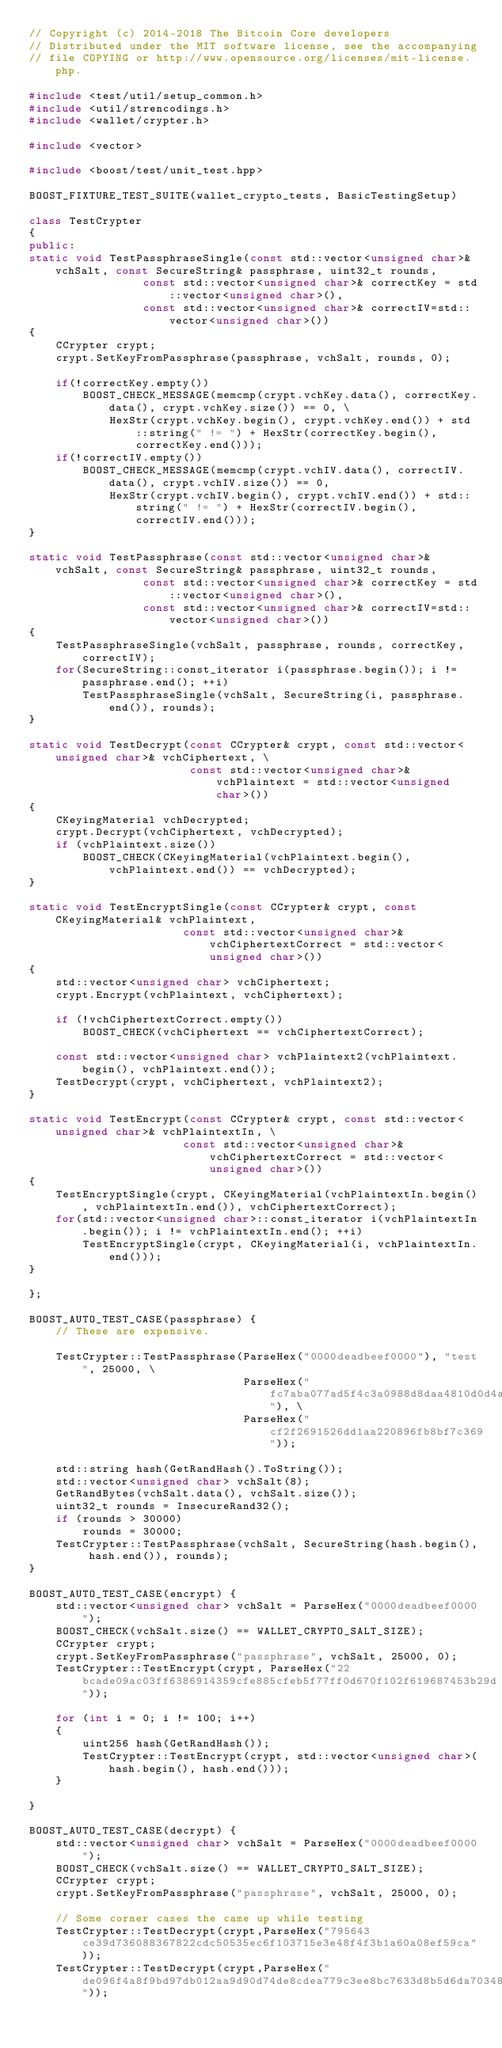<code> <loc_0><loc_0><loc_500><loc_500><_C++_>// Copyright (c) 2014-2018 The Bitcoin Core developers
// Distributed under the MIT software license, see the accompanying
// file COPYING or http://www.opensource.org/licenses/mit-license.php.

#include <test/util/setup_common.h>
#include <util/strencodings.h>
#include <wallet/crypter.h>

#include <vector>

#include <boost/test/unit_test.hpp>

BOOST_FIXTURE_TEST_SUITE(wallet_crypto_tests, BasicTestingSetup)

class TestCrypter
{
public:
static void TestPassphraseSingle(const std::vector<unsigned char>& vchSalt, const SecureString& passphrase, uint32_t rounds,
                 const std::vector<unsigned char>& correctKey = std::vector<unsigned char>(),
                 const std::vector<unsigned char>& correctIV=std::vector<unsigned char>())
{
    CCrypter crypt;
    crypt.SetKeyFromPassphrase(passphrase, vchSalt, rounds, 0);

    if(!correctKey.empty())
        BOOST_CHECK_MESSAGE(memcmp(crypt.vchKey.data(), correctKey.data(), crypt.vchKey.size()) == 0, \
            HexStr(crypt.vchKey.begin(), crypt.vchKey.end()) + std::string(" != ") + HexStr(correctKey.begin(), correctKey.end()));
    if(!correctIV.empty())
        BOOST_CHECK_MESSAGE(memcmp(crypt.vchIV.data(), correctIV.data(), crypt.vchIV.size()) == 0,
            HexStr(crypt.vchIV.begin(), crypt.vchIV.end()) + std::string(" != ") + HexStr(correctIV.begin(), correctIV.end()));
}

static void TestPassphrase(const std::vector<unsigned char>& vchSalt, const SecureString& passphrase, uint32_t rounds,
                 const std::vector<unsigned char>& correctKey = std::vector<unsigned char>(),
                 const std::vector<unsigned char>& correctIV=std::vector<unsigned char>())
{
    TestPassphraseSingle(vchSalt, passphrase, rounds, correctKey, correctIV);
    for(SecureString::const_iterator i(passphrase.begin()); i != passphrase.end(); ++i)
        TestPassphraseSingle(vchSalt, SecureString(i, passphrase.end()), rounds);
}

static void TestDecrypt(const CCrypter& crypt, const std::vector<unsigned char>& vchCiphertext, \
                        const std::vector<unsigned char>& vchPlaintext = std::vector<unsigned char>())
{
    CKeyingMaterial vchDecrypted;
    crypt.Decrypt(vchCiphertext, vchDecrypted);
    if (vchPlaintext.size())
        BOOST_CHECK(CKeyingMaterial(vchPlaintext.begin(), vchPlaintext.end()) == vchDecrypted);
}

static void TestEncryptSingle(const CCrypter& crypt, const CKeyingMaterial& vchPlaintext,
                       const std::vector<unsigned char>& vchCiphertextCorrect = std::vector<unsigned char>())
{
    std::vector<unsigned char> vchCiphertext;
    crypt.Encrypt(vchPlaintext, vchCiphertext);

    if (!vchCiphertextCorrect.empty())
        BOOST_CHECK(vchCiphertext == vchCiphertextCorrect);

    const std::vector<unsigned char> vchPlaintext2(vchPlaintext.begin(), vchPlaintext.end());
    TestDecrypt(crypt, vchCiphertext, vchPlaintext2);
}

static void TestEncrypt(const CCrypter& crypt, const std::vector<unsigned char>& vchPlaintextIn, \
                       const std::vector<unsigned char>& vchCiphertextCorrect = std::vector<unsigned char>())
{
    TestEncryptSingle(crypt, CKeyingMaterial(vchPlaintextIn.begin(), vchPlaintextIn.end()), vchCiphertextCorrect);
    for(std::vector<unsigned char>::const_iterator i(vchPlaintextIn.begin()); i != vchPlaintextIn.end(); ++i)
        TestEncryptSingle(crypt, CKeyingMaterial(i, vchPlaintextIn.end()));
}

};

BOOST_AUTO_TEST_CASE(passphrase) {
    // These are expensive.

    TestCrypter::TestPassphrase(ParseHex("0000deadbeef0000"), "test", 25000, \
                                ParseHex("fc7aba077ad5f4c3a0988d8daa4810d0d4a0e3bcb53af662998898f33df0556a"), \
                                ParseHex("cf2f2691526dd1aa220896fb8bf7c369"));

    std::string hash(GetRandHash().ToString());
    std::vector<unsigned char> vchSalt(8);
    GetRandBytes(vchSalt.data(), vchSalt.size());
    uint32_t rounds = InsecureRand32();
    if (rounds > 30000)
        rounds = 30000;
    TestCrypter::TestPassphrase(vchSalt, SecureString(hash.begin(), hash.end()), rounds);
}

BOOST_AUTO_TEST_CASE(encrypt) {
    std::vector<unsigned char> vchSalt = ParseHex("0000deadbeef0000");
    BOOST_CHECK(vchSalt.size() == WALLET_CRYPTO_SALT_SIZE);
    CCrypter crypt;
    crypt.SetKeyFromPassphrase("passphrase", vchSalt, 25000, 0);
    TestCrypter::TestEncrypt(crypt, ParseHex("22bcade09ac03ff6386914359cfe885cfeb5f77ff0d670f102f619687453b29d"));

    for (int i = 0; i != 100; i++)
    {
        uint256 hash(GetRandHash());
        TestCrypter::TestEncrypt(crypt, std::vector<unsigned char>(hash.begin(), hash.end()));
    }

}

BOOST_AUTO_TEST_CASE(decrypt) {
    std::vector<unsigned char> vchSalt = ParseHex("0000deadbeef0000");
    BOOST_CHECK(vchSalt.size() == WALLET_CRYPTO_SALT_SIZE);
    CCrypter crypt;
    crypt.SetKeyFromPassphrase("passphrase", vchSalt, 25000, 0);

    // Some corner cases the came up while testing
    TestCrypter::TestDecrypt(crypt,ParseHex("795643ce39d736088367822cdc50535ec6f103715e3e48f4f3b1a60a08ef59ca"));
    TestCrypter::TestDecrypt(crypt,ParseHex("de096f4a8f9bd97db012aa9d90d74de8cdea779c3ee8bc7633d8b5d6da703486"));</code> 